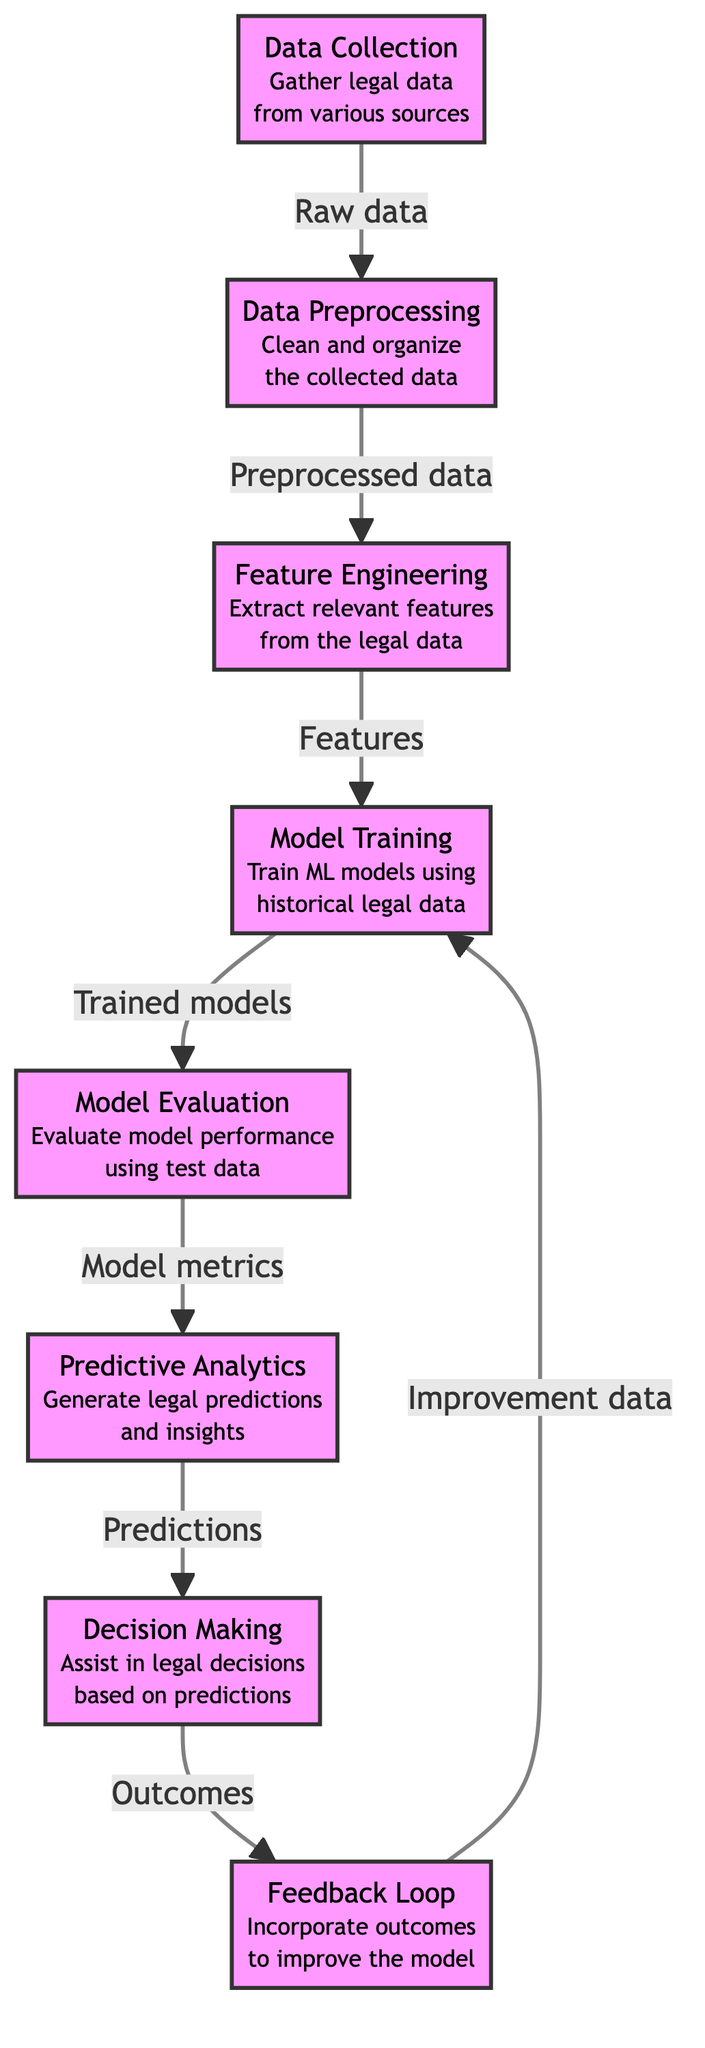What is the first step in the diagram? The first node in the diagram is "Data Collection", which is indicated at the top. This is the starting point of the process, where legal data is gathered from various sources.
Answer: Data Collection How many nodes are present in the diagram? By counting all the unique steps represented in the diagram, we find there are eight distinct nodes, each representing a specific phase in the process.
Answer: 8 What type of data flows from "Data Preprocessing" to "Feature Engineering"? The arrow indicates that "Preprocessed data" flows from "Data Preprocessing" to "Feature Engineering", showing the transition of data between these stages.
Answer: Preprocessed data Which node generates predictions and insights? The "Predictive Analytics" node specifically indicates the generation of legal predictions and insights, as labeled in the flowchart.
Answer: Predictive Analytics What does the "Feedback Loop" aim to achieve? The "Feedback Loop" is focused on incorporating outcomes to improve the model, as indicated in the diagram. This step highlights the cyclical nature of model refinement.
Answer: Improve the model What action is performed after "Model Evaluation"? After "Model Evaluation", the next action is "Predictive Analytics", which uses the evaluated models to generate predictions and insights based on the test data.
Answer: Predictive Analytics Which node acts as a bridge between "Model Training" and "Model Evaluation"? The "Model Evaluation" node connects specifically after "Model Training", indicating that model training is a prerequisite for evaluating model performance with test data.
Answer: Model Evaluation What kind of data does "Decision Making" utilize? The node labeled "Decision Making" utilizes the "Predictions" generated by the "Predictive Analytics" node to assist in legal decisions.
Answer: Predictions 